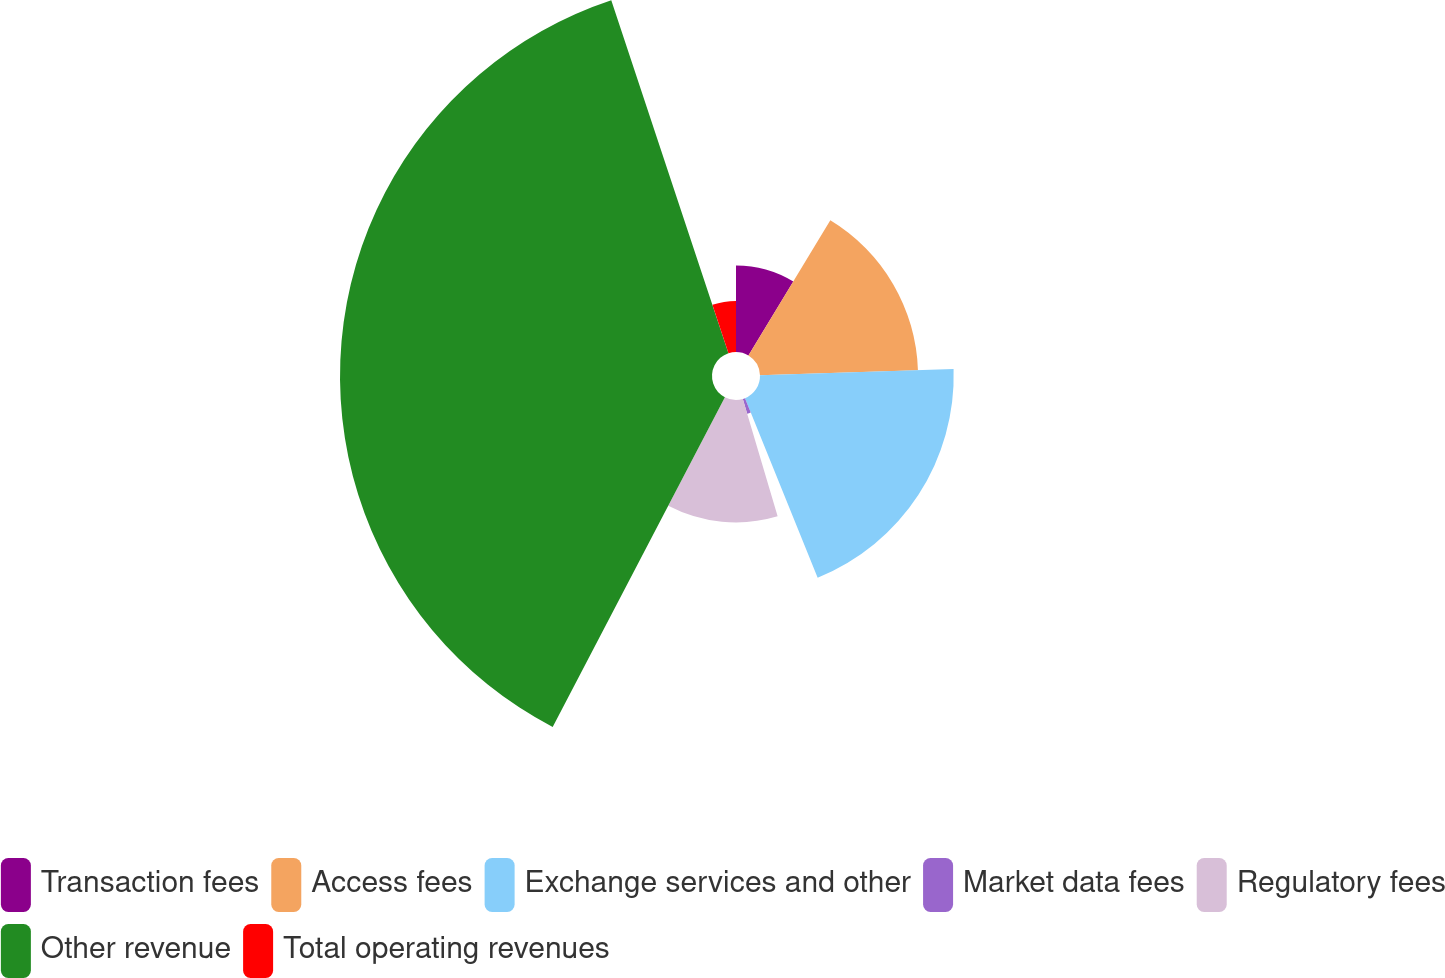Convert chart. <chart><loc_0><loc_0><loc_500><loc_500><pie_chart><fcel>Transaction fees<fcel>Access fees<fcel>Exchange services and other<fcel>Market data fees<fcel>Regulatory fees<fcel>Other revenue<fcel>Total operating revenues<nl><fcel>8.67%<fcel>15.82%<fcel>19.39%<fcel>1.53%<fcel>12.25%<fcel>37.24%<fcel>5.1%<nl></chart> 